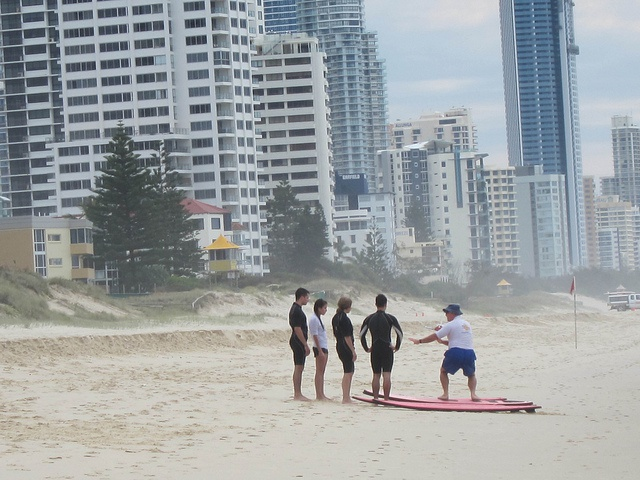Describe the objects in this image and their specific colors. I can see people in gray, black, darkgray, and lightgray tones, people in gray, navy, and darkgray tones, people in gray, black, and darkgray tones, people in gray, black, and darkgray tones, and people in gray, darkgray, and black tones in this image. 